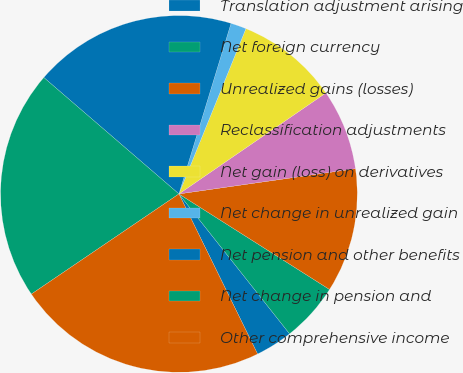<chart> <loc_0><loc_0><loc_500><loc_500><pie_chart><fcel>Translation adjustment arising<fcel>Net foreign currency<fcel>Unrealized gains (losses)<fcel>Reclassification adjustments<fcel>Net gain (loss) on derivatives<fcel>Net change in unrealized gain<fcel>Net pension and other benefits<fcel>Net change in pension and<fcel>Other comprehensive income<nl><fcel>3.38%<fcel>5.35%<fcel>11.26%<fcel>7.32%<fcel>9.29%<fcel>1.41%<fcel>18.4%<fcel>20.81%<fcel>22.78%<nl></chart> 